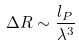<formula> <loc_0><loc_0><loc_500><loc_500>\Delta R \sim \frac { l _ { P } } { \lambda ^ { 3 } }</formula> 